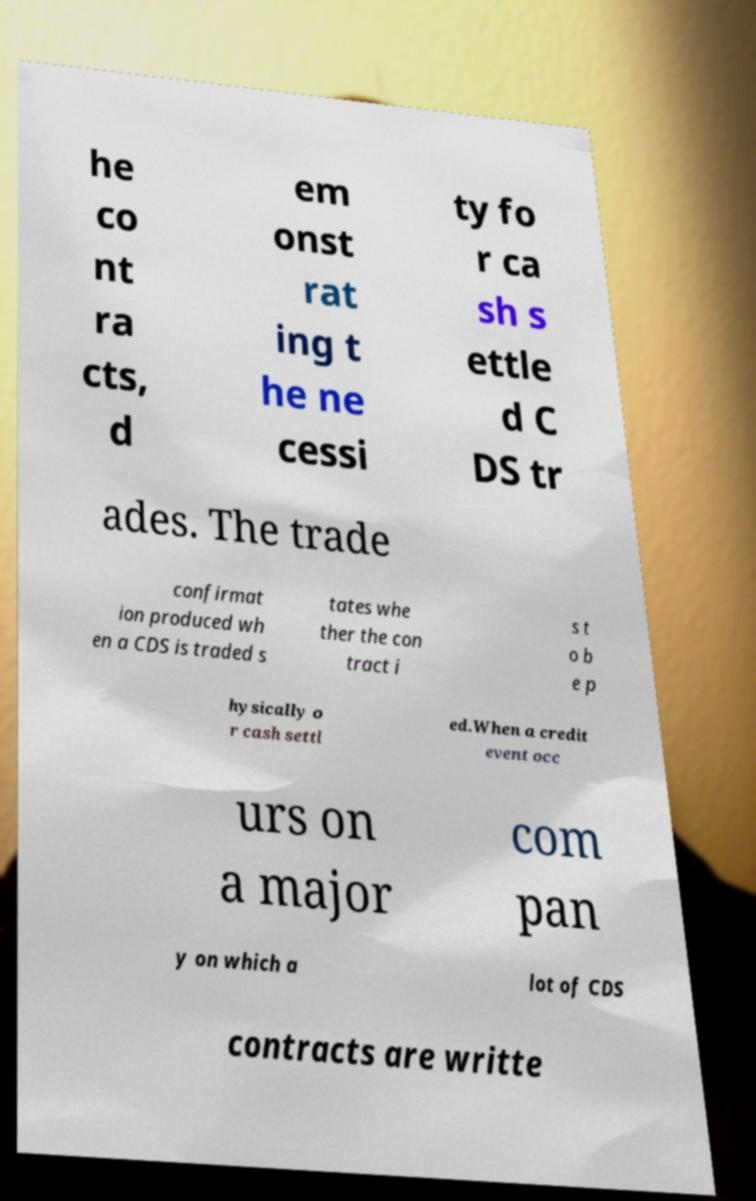What messages or text are displayed in this image? I need them in a readable, typed format. he co nt ra cts, d em onst rat ing t he ne cessi ty fo r ca sh s ettle d C DS tr ades. The trade confirmat ion produced wh en a CDS is traded s tates whe ther the con tract i s t o b e p hysically o r cash settl ed.When a credit event occ urs on a major com pan y on which a lot of CDS contracts are writte 